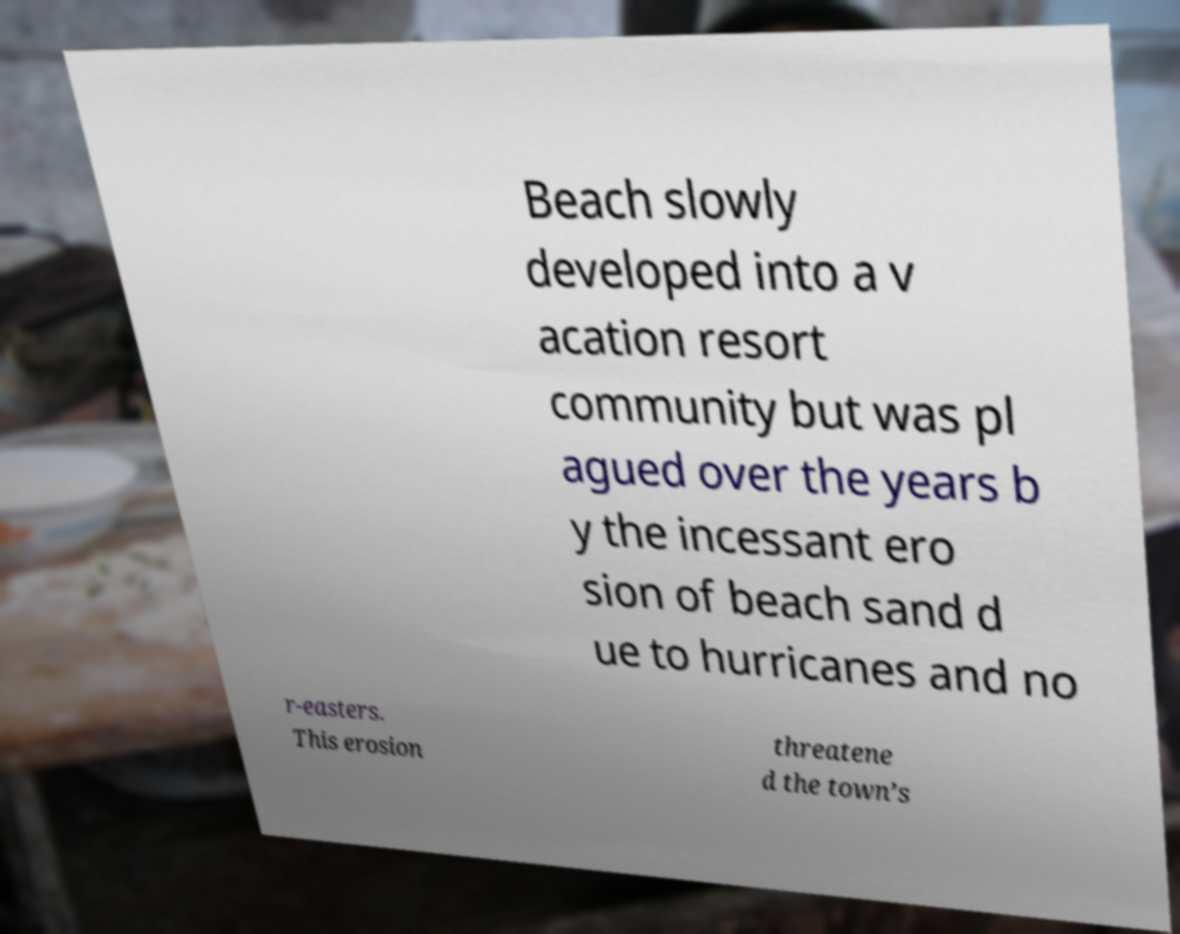I need the written content from this picture converted into text. Can you do that? Beach slowly developed into a v acation resort community but was pl agued over the years b y the incessant ero sion of beach sand d ue to hurricanes and no r-easters. This erosion threatene d the town’s 